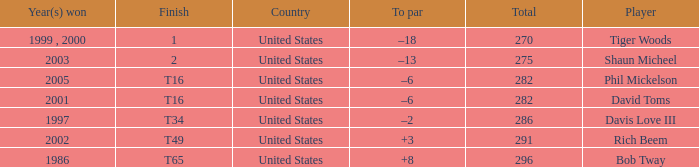What is the to par number of the person who won in 2003? –13. 